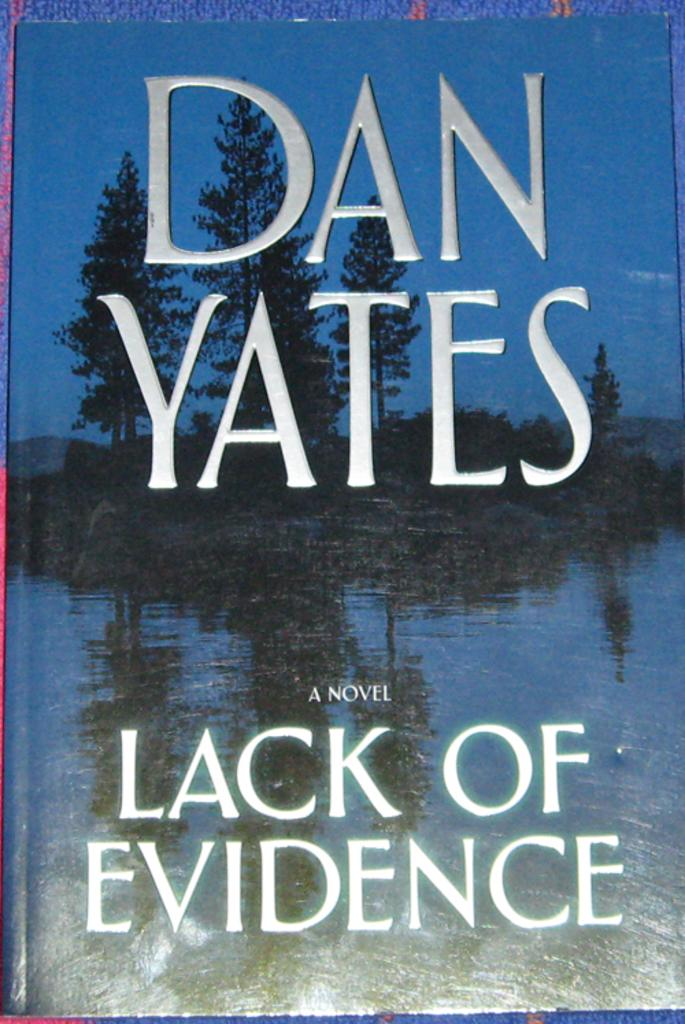What object is placed on the table in the image? There is a book on a table in the image. What can be found on the book in the image? There is text visible on the book in the image. What type of thread is being used to sew the hand in the image? There is no hand or thread present in the image; it only features a book on a table with visible text. 